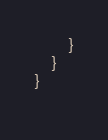<code> <loc_0><loc_0><loc_500><loc_500><_JavaScript_>        }
    }
}
 </code> 